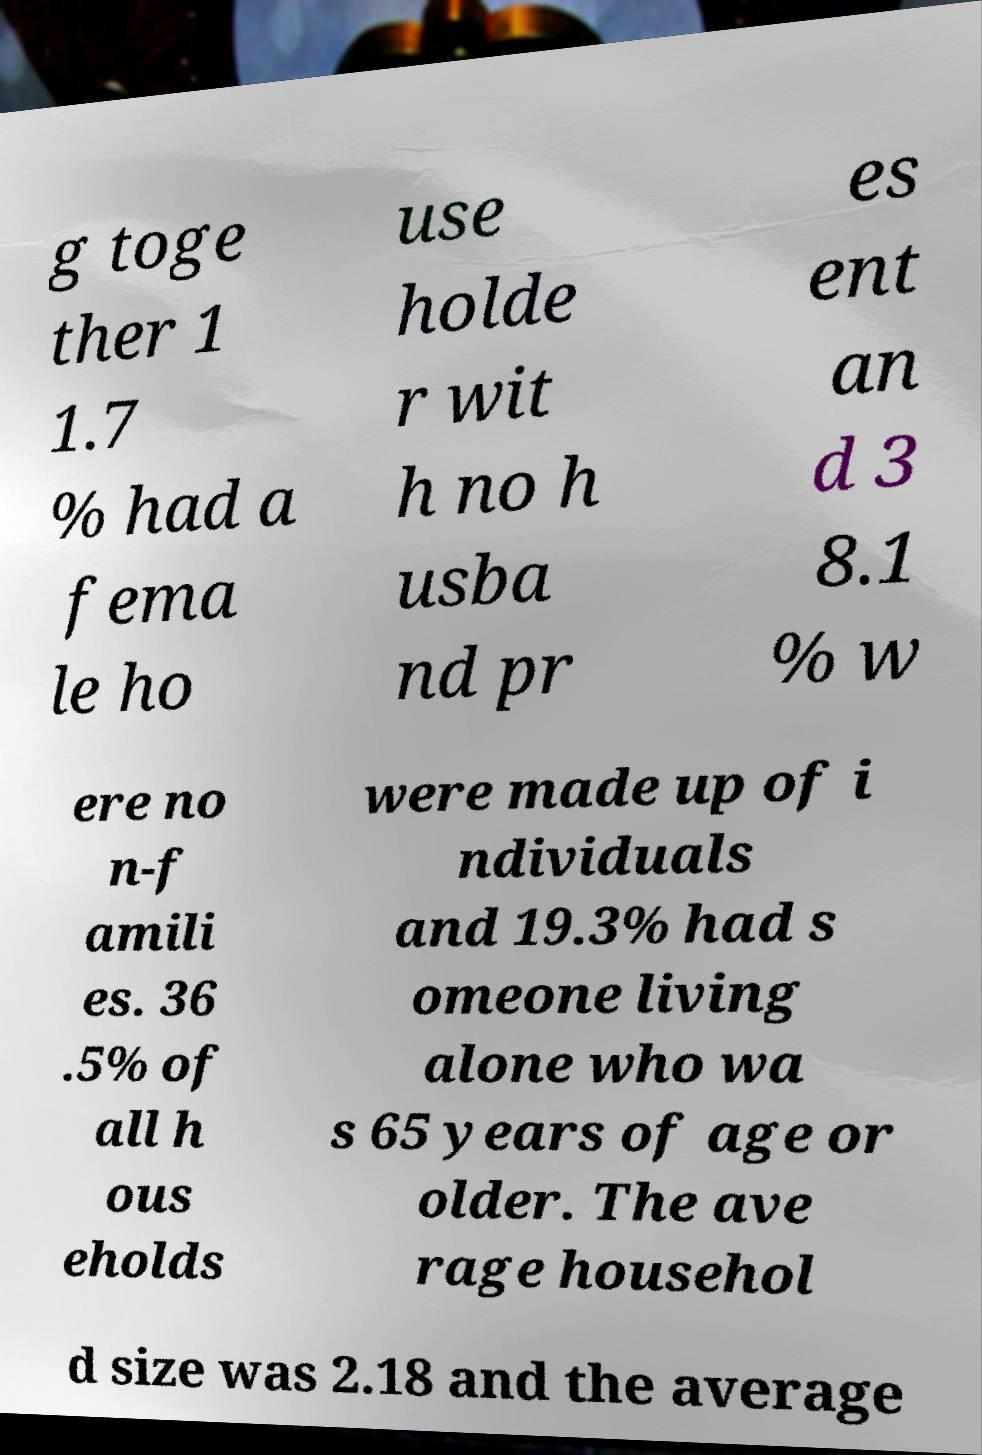What messages or text are displayed in this image? I need them in a readable, typed format. g toge ther 1 1.7 % had a fema le ho use holde r wit h no h usba nd pr es ent an d 3 8.1 % w ere no n-f amili es. 36 .5% of all h ous eholds were made up of i ndividuals and 19.3% had s omeone living alone who wa s 65 years of age or older. The ave rage househol d size was 2.18 and the average 